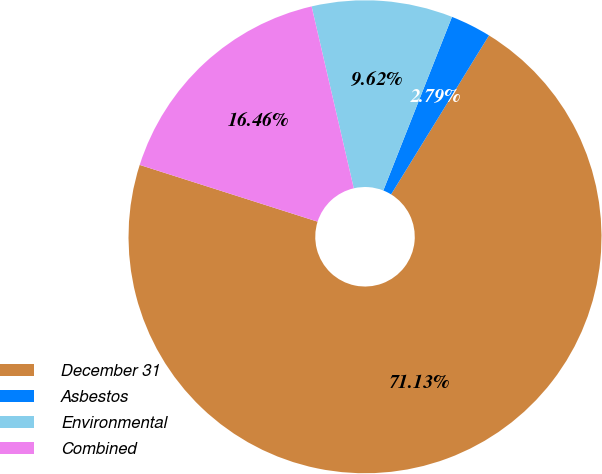Convert chart to OTSL. <chart><loc_0><loc_0><loc_500><loc_500><pie_chart><fcel>December 31<fcel>Asbestos<fcel>Environmental<fcel>Combined<nl><fcel>71.13%<fcel>2.79%<fcel>9.62%<fcel>16.46%<nl></chart> 